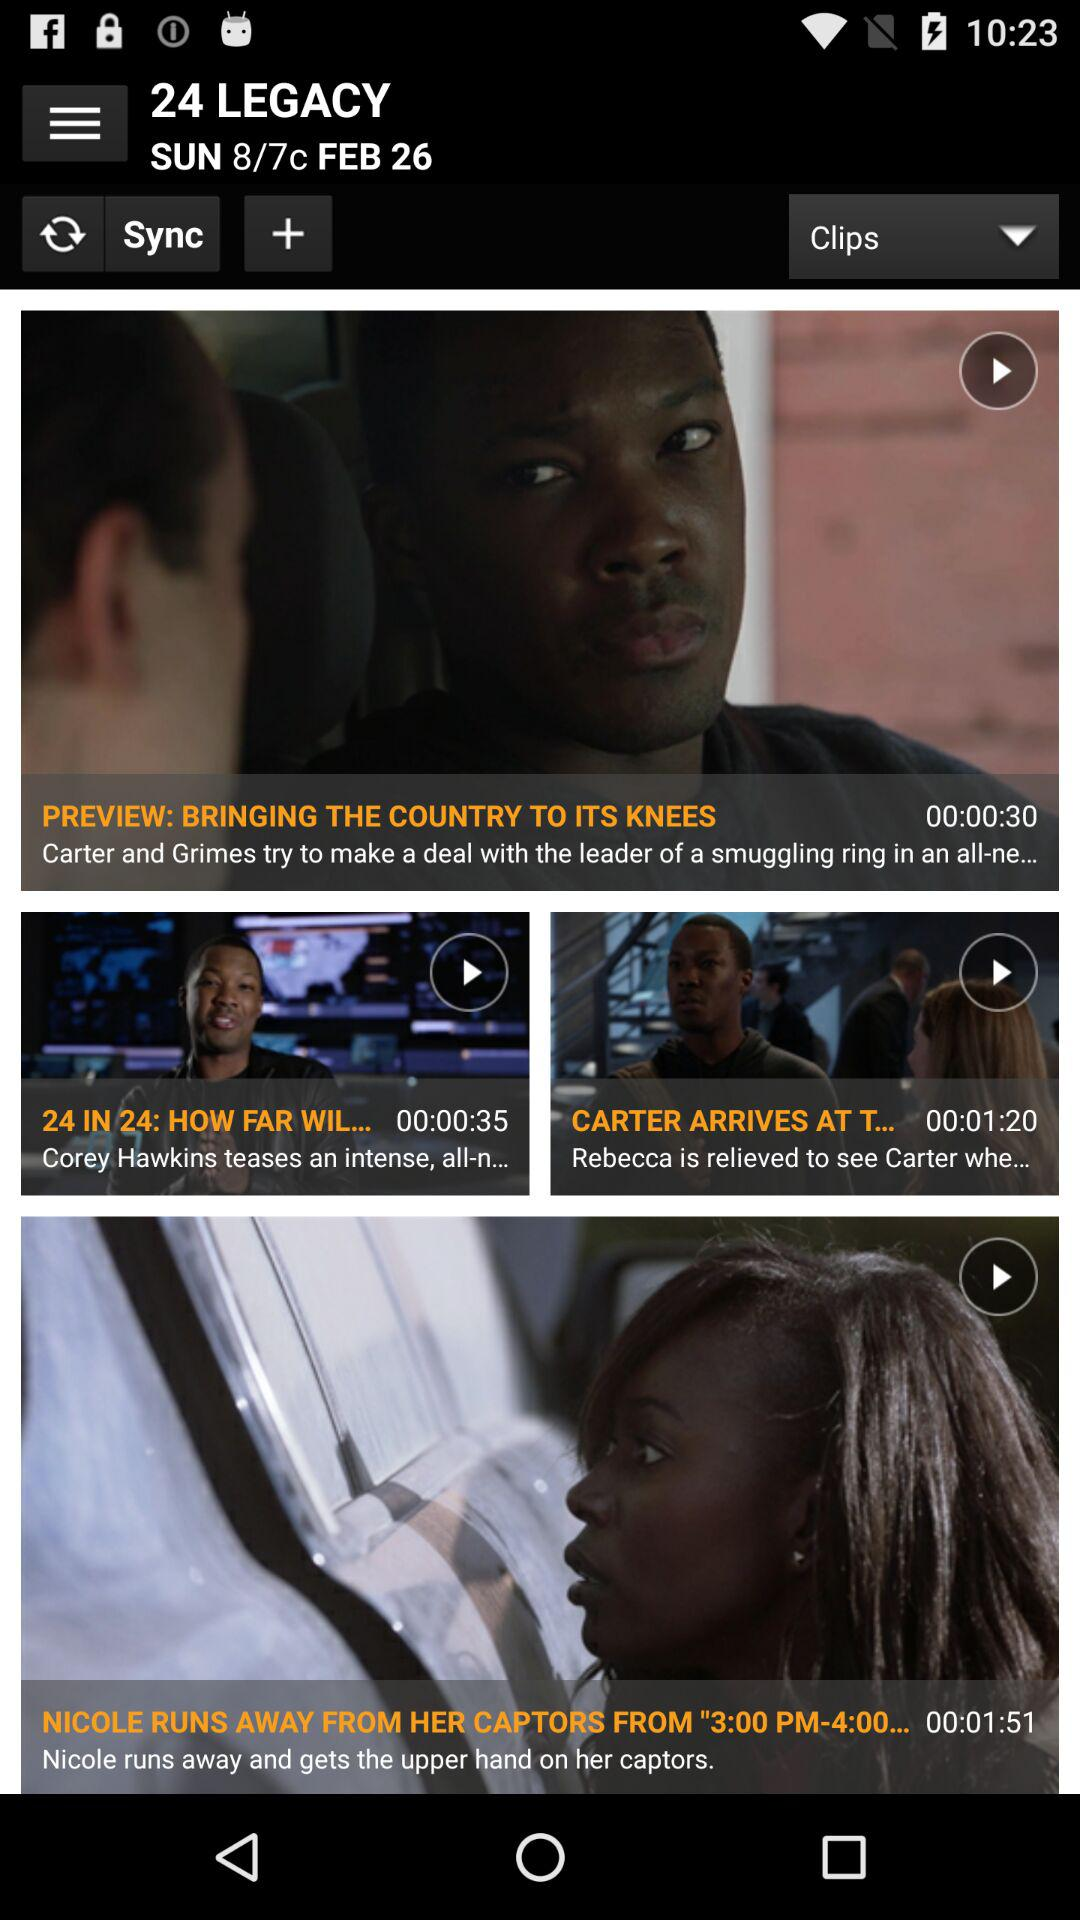When is the show scheduled to air? The show is scheduled to air on Sunday, February 26 at 8/7c. 